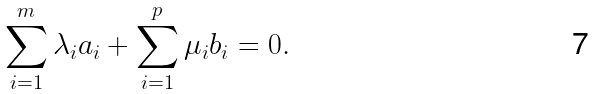<formula> <loc_0><loc_0><loc_500><loc_500>\sum _ { i = 1 } ^ { m } \lambda _ { i } a _ { i } + \sum _ { i = 1 } ^ { p } \mu _ { i } b _ { i } = 0 .</formula> 